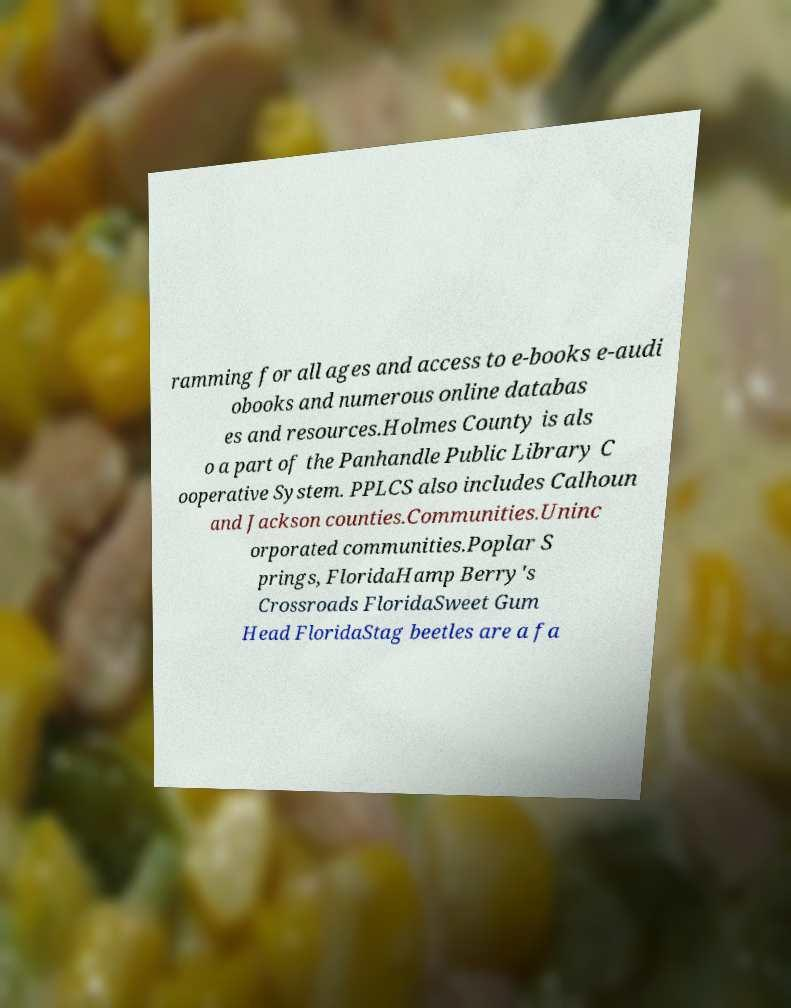Please read and relay the text visible in this image. What does it say? ramming for all ages and access to e-books e-audi obooks and numerous online databas es and resources.Holmes County is als o a part of the Panhandle Public Library C ooperative System. PPLCS also includes Calhoun and Jackson counties.Communities.Uninc orporated communities.Poplar S prings, FloridaHamp Berry's Crossroads FloridaSweet Gum Head FloridaStag beetles are a fa 